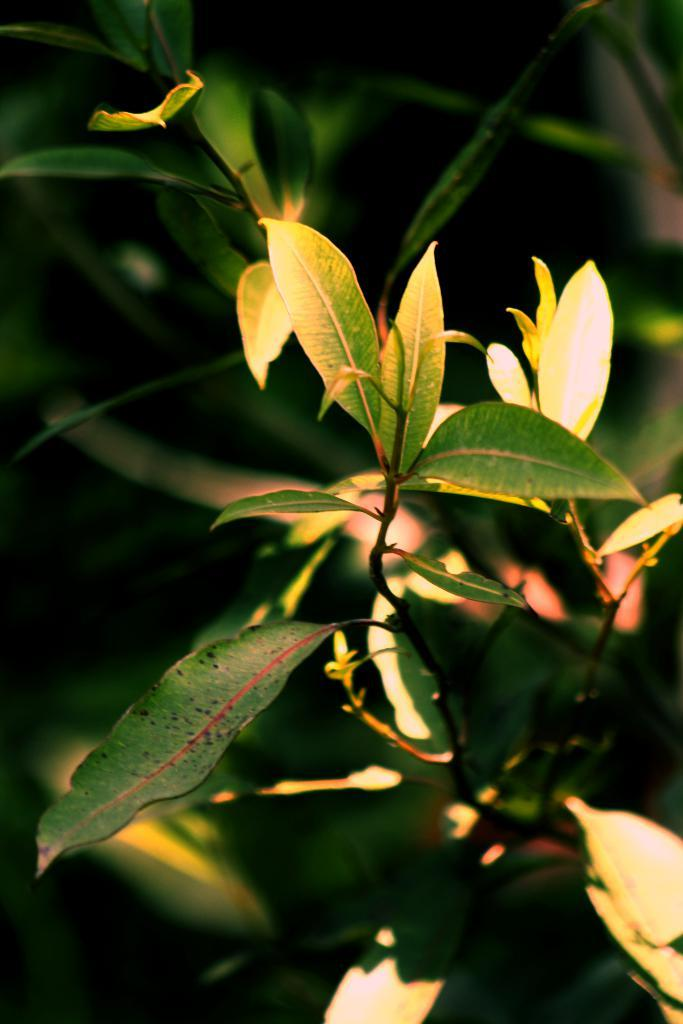What type of plant is visible in the image? There is a plant with green leaves in the picture. Can you describe the background of the image? The background of the image is blurred. How many stamps are on the kite in the image? There is no kite or stamp present in the image. 